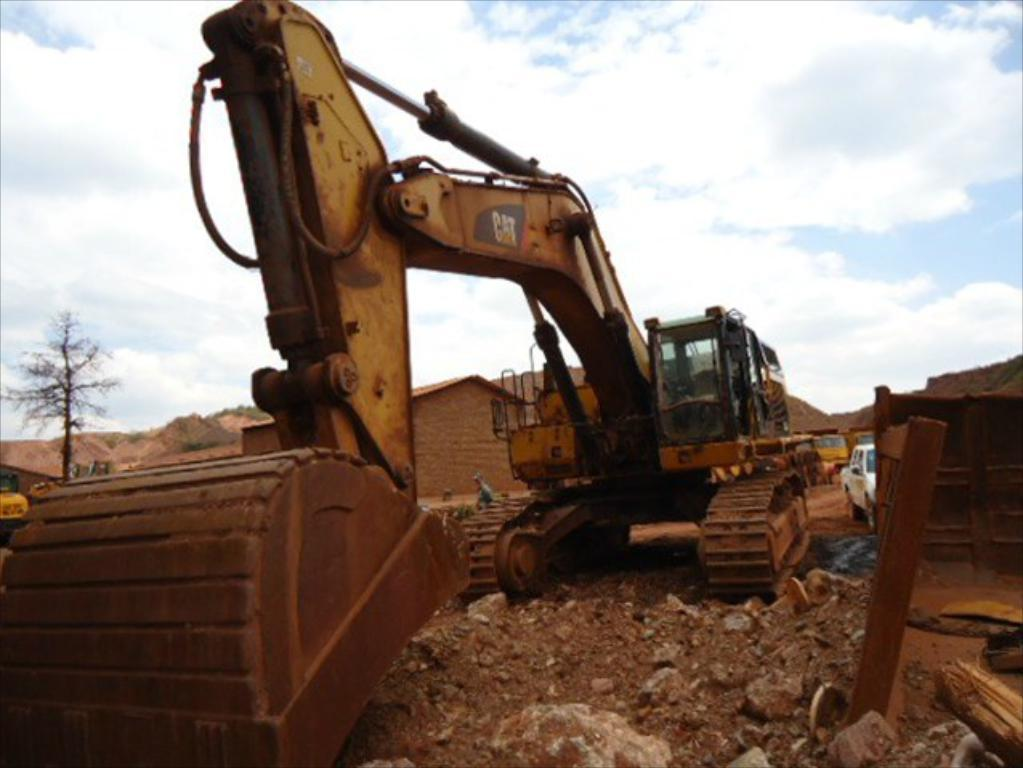What type of machinery is present in the image? There is an excavator in the image. What can be seen behind the excavator? There are vehicles, buildings, and trees behind the excavator. What is visible at the top of the image? Clouds and the sky are visible at the top of the image. How many crows are perched on the excavator's wing in the image? There is no wing or crow present in the image; it features an excavator and other objects and elements. 